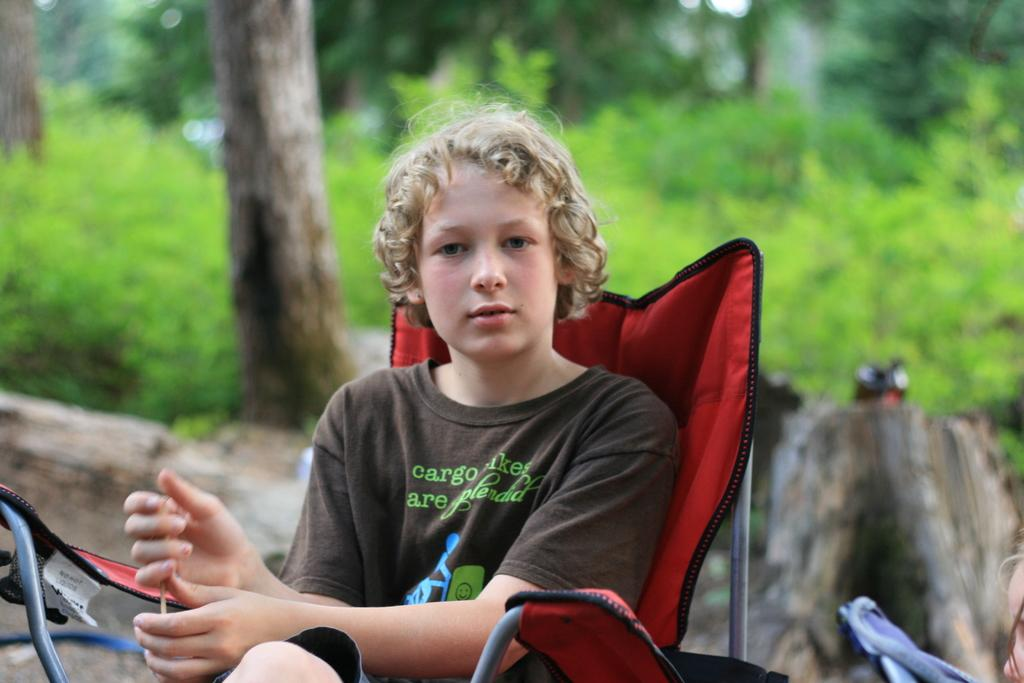Who is the main subject in the image? There is a boy in the image. What is the boy doing in the image? The boy is sitting on a chair. What type of natural environment can be seen in the image? There are trees visible in the image. Can you describe a specific part of a tree that is visible in the image? There is a tree trunk visible in the image. What type of fang can be seen in the image? There are no fangs present in the image. How many frogs are visible in the image? There are no frogs visible in the image. 